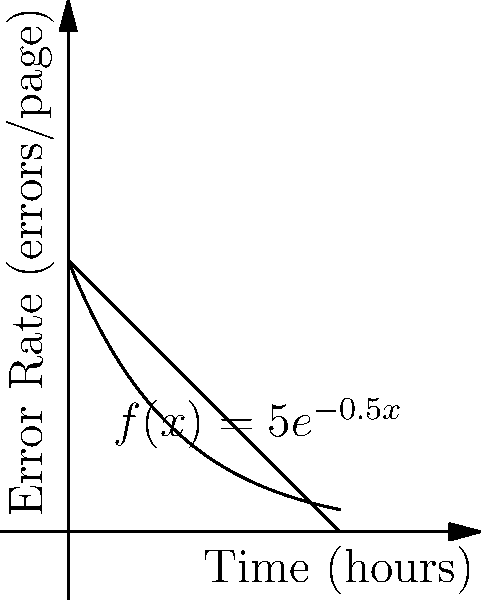As a prescriptivist grammarian, you're analyzing a large text corpus for grammatical errors. The error rate (in errors per page) over time (in hours) is modeled by the function $f(x) = 5e^{-0.5x}$, where $x$ is the time spent proofreading. Calculate the total number of errors found in the first 5 hours of proofreading, assuming each hour corresponds to reviewing 60 pages. Round your answer to the nearest whole number. To solve this problem, we need to follow these steps:

1) The total number of errors is represented by the area under the curve $f(x) = 5e^{-0.5x}$ from $x = 0$ to $x = 5$.

2) We can calculate this area using a definite integral:

   $\int_0^5 5e^{-0.5x} dx$

3) To solve this integral, we use the substitution method:
   Let $u = -0.5x$, then $du = -0.5dx$ or $dx = -2du$
   When $x = 0$, $u = 0$; when $x = 5$, $u = -2.5$

4) Rewriting the integral:

   $-10 \int_0^{-2.5} e^u du = -10 [e^u]_0^{-2.5} = -10(e^{-2.5} - e^0) = 10(1 - e^{-2.5})$

5) Evaluating this:

   $10(1 - e^{-2.5}) \approx 9.18$

6) This result represents errors per page. To get the total number of errors, we multiply by 60 pages per hour for 5 hours:

   $9.18 * 60 * 5 = 2754$

7) Rounding to the nearest whole number: 2754
Answer: 2754 errors 